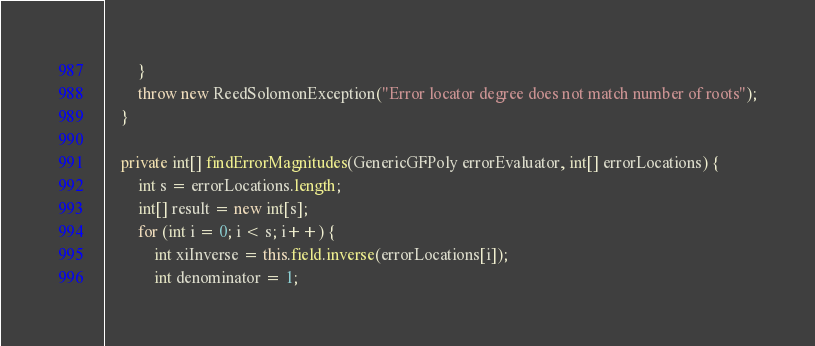<code> <loc_0><loc_0><loc_500><loc_500><_Java_>        }
        throw new ReedSolomonException("Error locator degree does not match number of roots");
    }

    private int[] findErrorMagnitudes(GenericGFPoly errorEvaluator, int[] errorLocations) {
        int s = errorLocations.length;
        int[] result = new int[s];
        for (int i = 0; i < s; i++) {
            int xiInverse = this.field.inverse(errorLocations[i]);
            int denominator = 1;</code> 